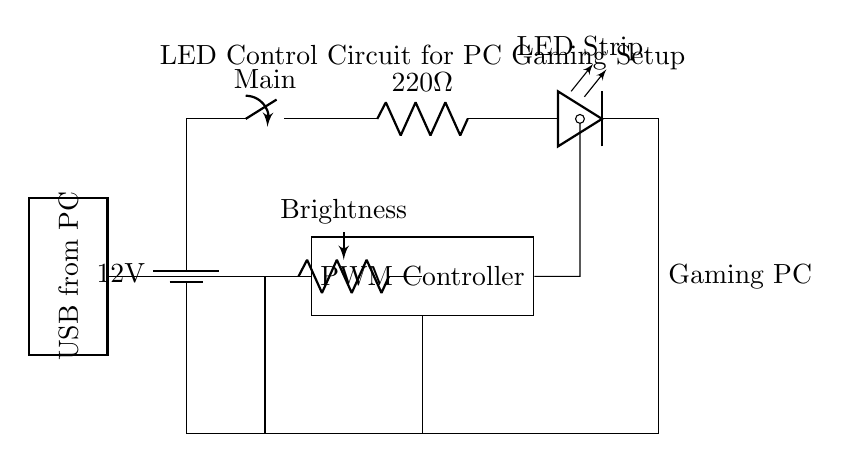What voltage does the power supply provide? The circuit shows a battery labeled with a voltage of 12 volts connected at the start of the circuit diagram. This indicates that the power supply provides a voltage of 12V.
Answer: 12 volts What component is used for brightness control? The circuit diagram includes a potentiometer labeled as "Brightness." This indicates that the brightness control is achieved using a potentiometer.
Answer: Potentiometer How many resistors are present in the circuit? The circuit diagram features one current limiting resistor labeled "220 ohm." There are no other resistors indicated in the circuit, so the total is one.
Answer: One What is the purpose of the PWM controller in this circuit? The PWM (Pulse Width Modulation) controller is used to adjust the brightness of the LED strip by controlling the amount of power delivered to it. This is indicated by its connection to both the potentiometer and the LED strip.
Answer: Brightness control What is the function of the main switch in the circuit? The main switch connects or disconnects the power supply to the rest of the circuit. This means that when the switch is open, no power flows to the components, and when closed, power is supplied to the circuit.
Answer: Power on/off What is the current limiting resistor's value in the circuit? The current limiting resistor in the circuitry is labeled as "220 ohm," which shows its resistance value directly in the circuit diagram.
Answer: 220 ohm Where does the USB connection come from? The circuit diagram indicates a USB connection that comes from the PC, which is visually represented on the left side of the diagram and is labeled as "USB from PC."
Answer: PC 